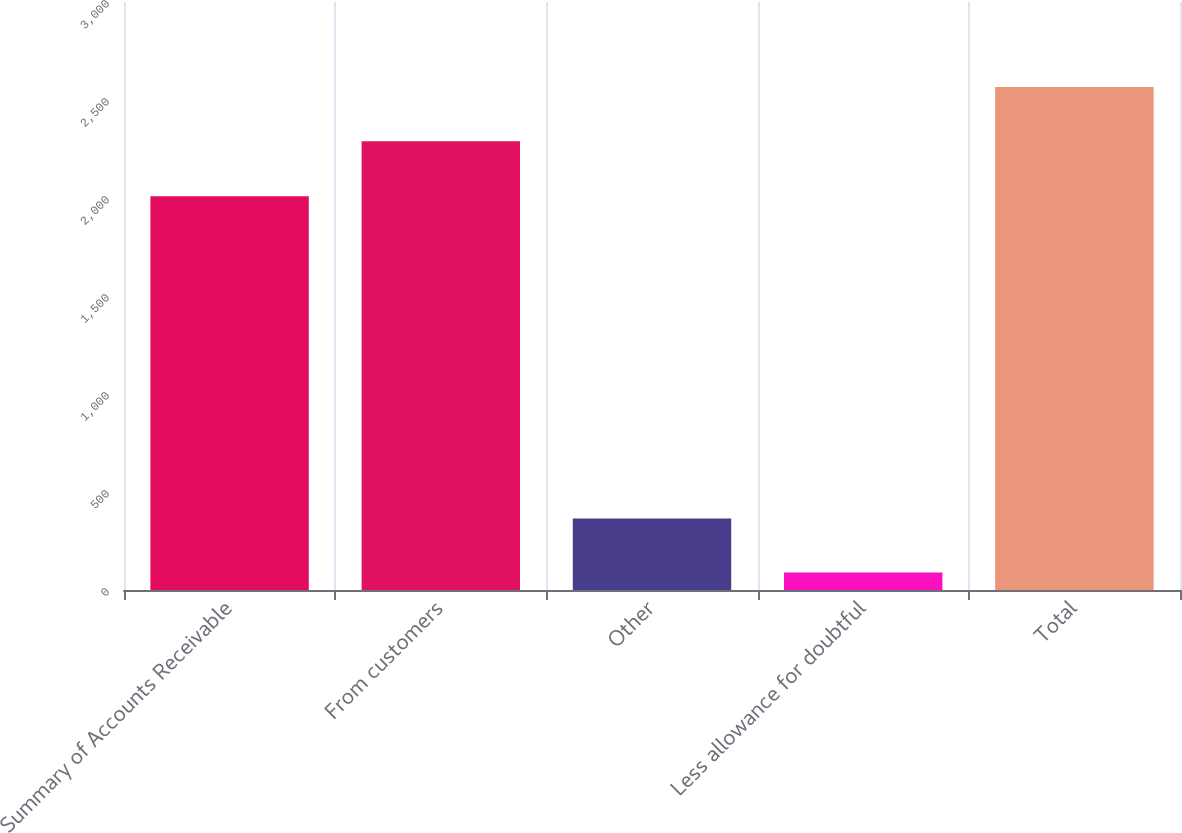Convert chart. <chart><loc_0><loc_0><loc_500><loc_500><bar_chart><fcel>Summary of Accounts Receivable<fcel>From customers<fcel>Other<fcel>Less allowance for doubtful<fcel>Total<nl><fcel>2009<fcel>2290<fcel>365<fcel>89<fcel>2566<nl></chart> 